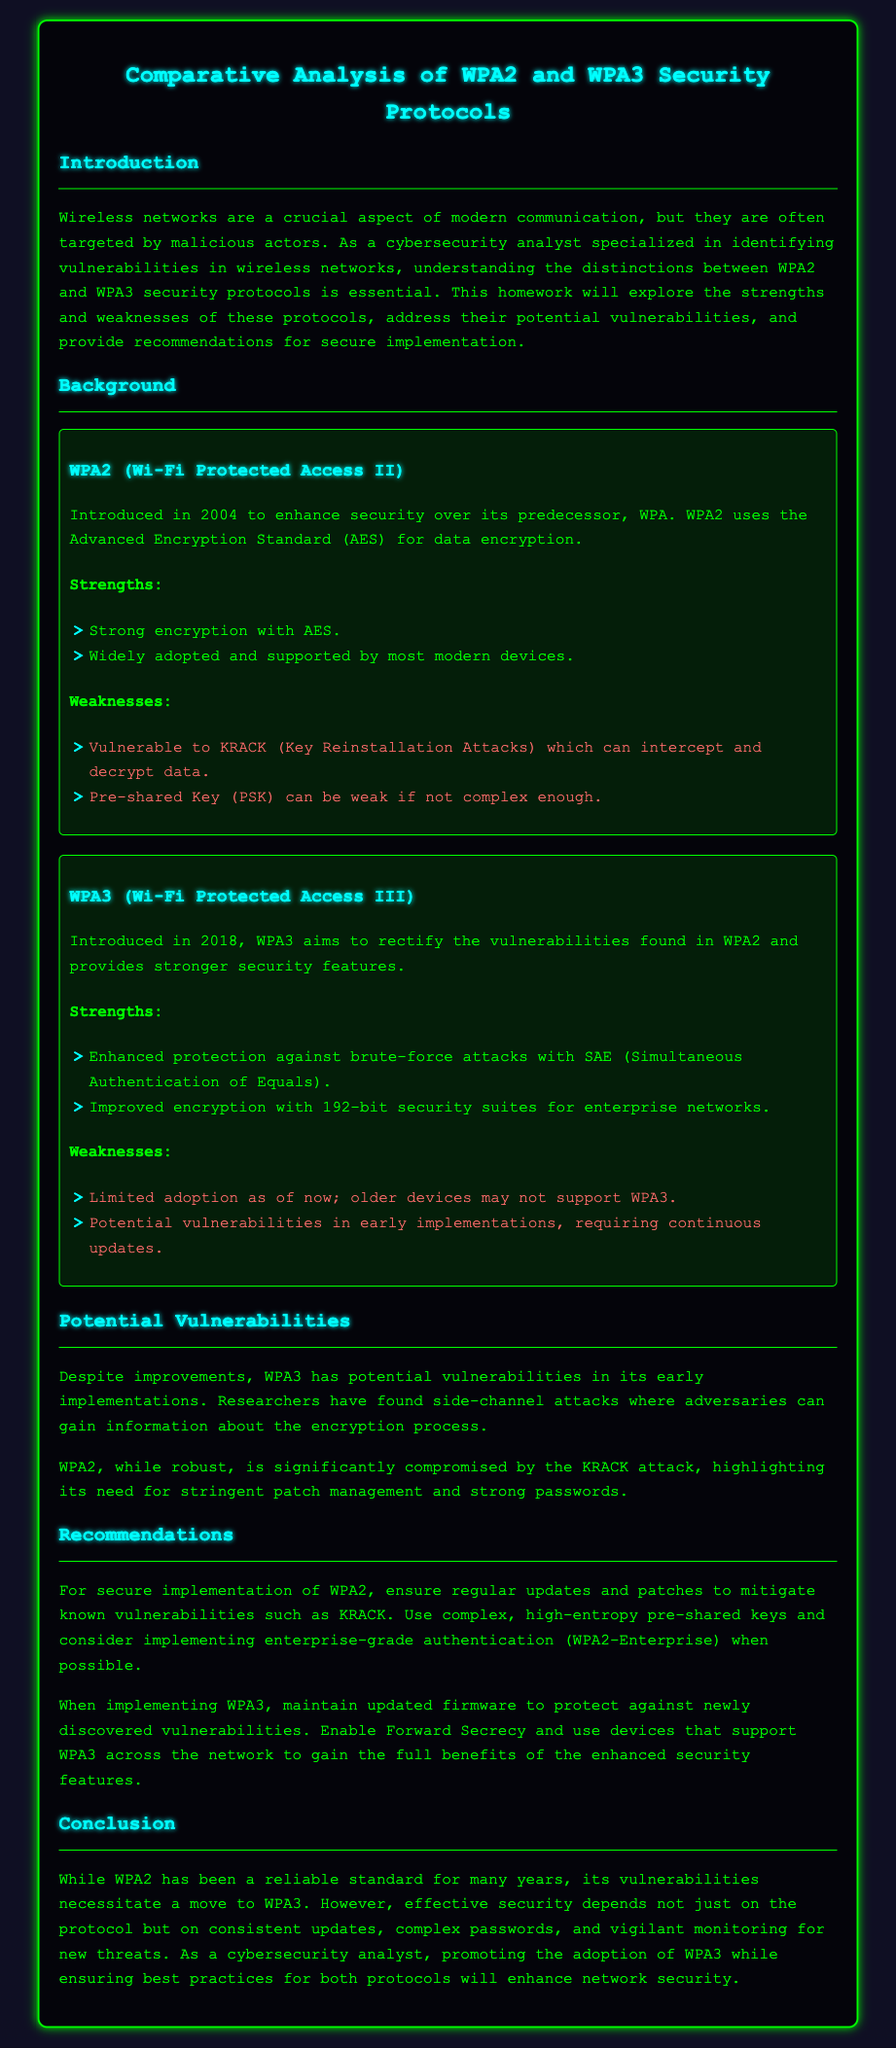What year was WPA2 introduced? WPA2 was introduced in 2004, as mentioned in the document.
Answer: 2004 What encryption standard does WPA2 use? The document specifies that WPA2 uses the Advanced Encryption Standard (AES) for data encryption.
Answer: AES What is a strength of WPA3 related to brute-force attacks? The document highlights that WPA3 provides enhanced protection against brute-force attacks with SAE.
Answer: SAE What vulnerability is associated with WPA2? The document states that WPA2 is vulnerable to KRACK (Key Reinstallation Attacks).
Answer: KRACK Which security protocol has improved encryption for enterprise networks? The document indicates that WPA3 has improved encryption with 192-bit security suites for enterprise networks.
Answer: WPA3 What is recommended for secure implementation of WPA2? The document recommends ensuring regular updates and using complex pre-shared keys for the secure implementation of WPA2.
Answer: Regular updates and complex keys What potential vulnerability exists in early implementations of WPA3? The document mentions potential vulnerabilities in early implementations of WPA3 that can be exploited through side-channel attacks.
Answer: Side-channel attacks How does the document suggest to maintain security when implementing WPA3? The document advises maintaining updated firmware to protect against newly discovered vulnerabilities when implementing WPA3.
Answer: Updated firmware Which protocol is suggested to promote for better network security? The document concludes that promoting the adoption of WPA3 will enhance network security.
Answer: WPA3 